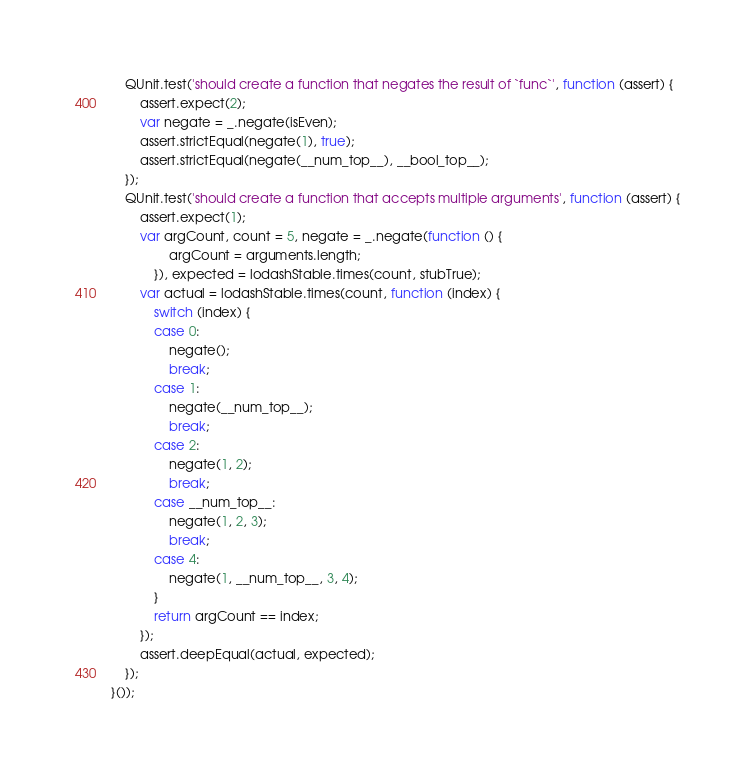<code> <loc_0><loc_0><loc_500><loc_500><_JavaScript_>    QUnit.test('should create a function that negates the result of `func`', function (assert) {
        assert.expect(2);
        var negate = _.negate(isEven);
        assert.strictEqual(negate(1), true);
        assert.strictEqual(negate(__num_top__), __bool_top__);
    });
    QUnit.test('should create a function that accepts multiple arguments', function (assert) {
        assert.expect(1);
        var argCount, count = 5, negate = _.negate(function () {
                argCount = arguments.length;
            }), expected = lodashStable.times(count, stubTrue);
        var actual = lodashStable.times(count, function (index) {
            switch (index) {
            case 0:
                negate();
                break;
            case 1:
                negate(__num_top__);
                break;
            case 2:
                negate(1, 2);
                break;
            case __num_top__:
                negate(1, 2, 3);
                break;
            case 4:
                negate(1, __num_top__, 3, 4);
            }
            return argCount == index;
        });
        assert.deepEqual(actual, expected);
    });
}());</code> 